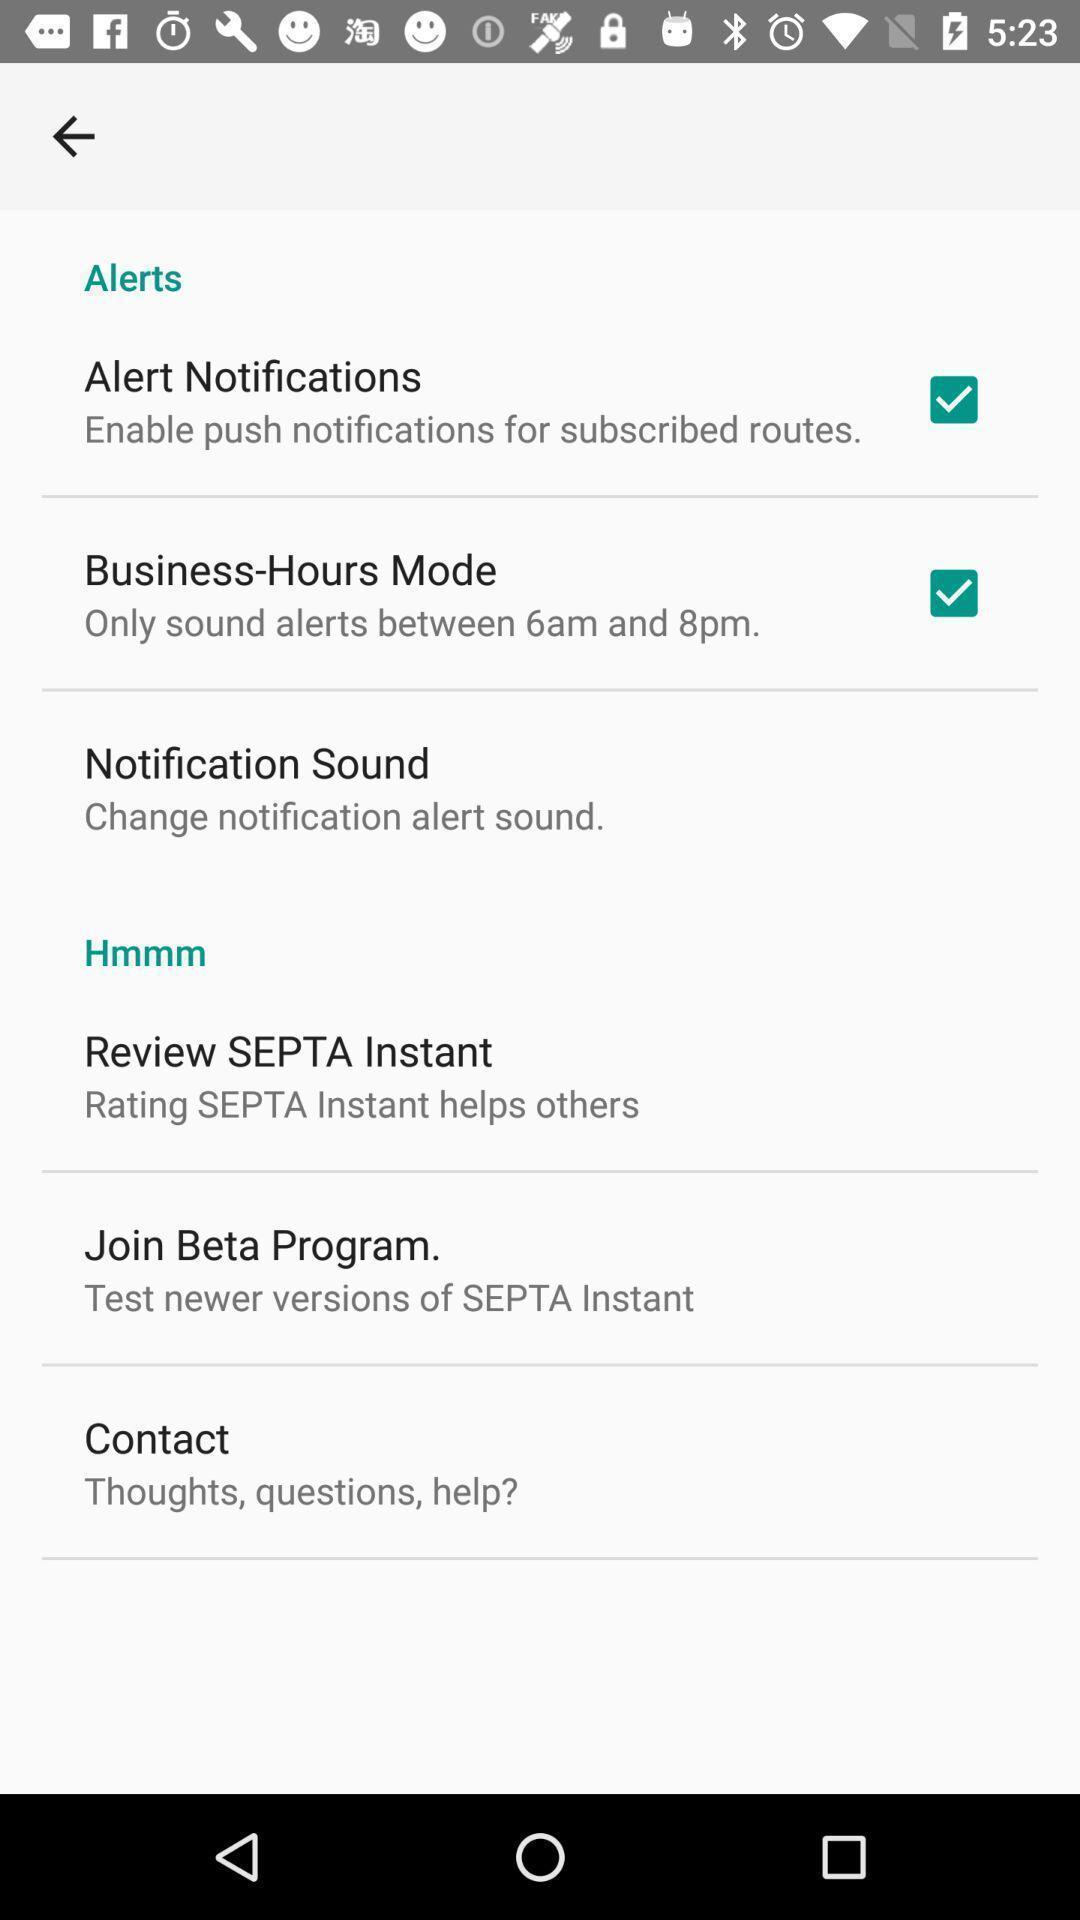Explain what's happening in this screen capture. Settings page. 